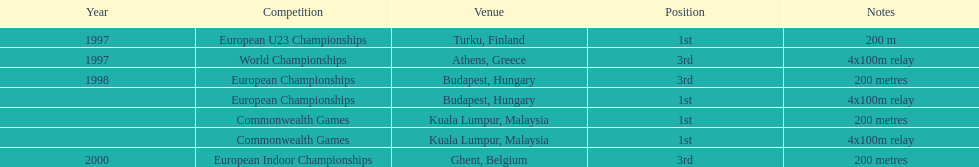In what year did england achieve the greatest success in the 200 meter? 1997. 